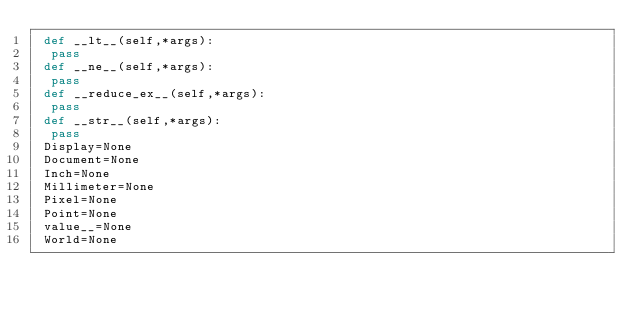<code> <loc_0><loc_0><loc_500><loc_500><_Python_> def __lt__(self,*args):
  pass
 def __ne__(self,*args):
  pass
 def __reduce_ex__(self,*args):
  pass
 def __str__(self,*args):
  pass
 Display=None
 Document=None
 Inch=None
 Millimeter=None
 Pixel=None
 Point=None
 value__=None
 World=None

</code> 